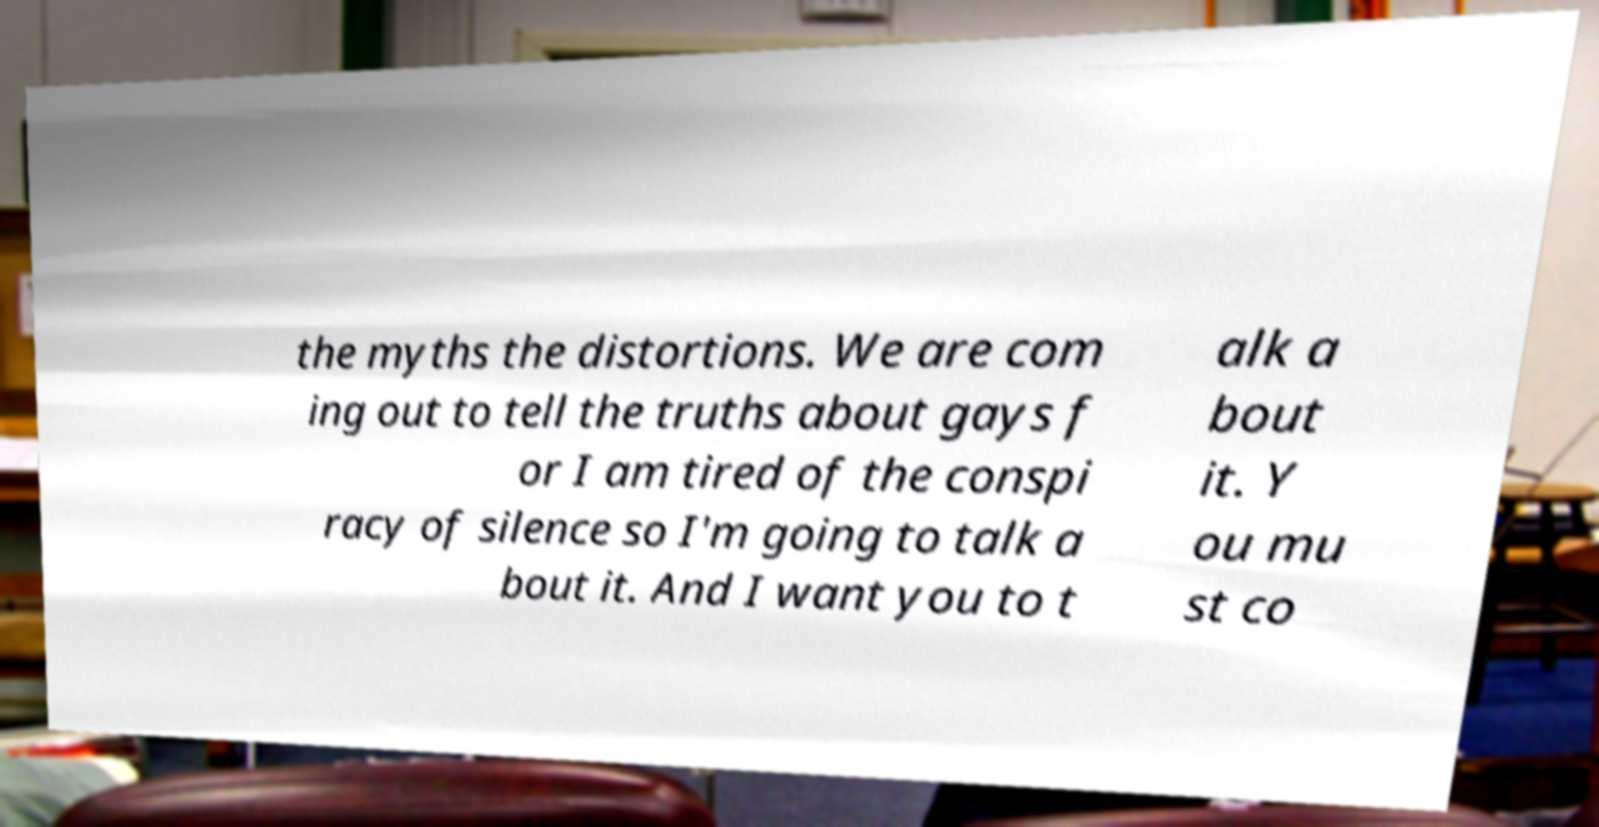Could you extract and type out the text from this image? the myths the distortions. We are com ing out to tell the truths about gays f or I am tired of the conspi racy of silence so I'm going to talk a bout it. And I want you to t alk a bout it. Y ou mu st co 